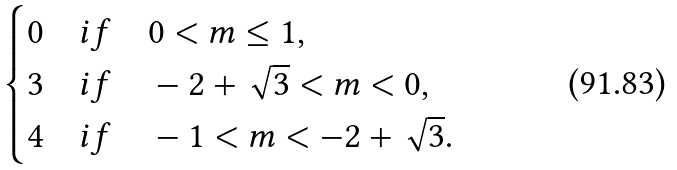<formula> <loc_0><loc_0><loc_500><loc_500>\begin{cases} 0 & i f \quad 0 < m \leq 1 , \\ 3 & i f \quad - 2 + \sqrt { 3 } < m < 0 , \\ 4 & i f \quad - 1 < m < - 2 + \sqrt { 3 } . \end{cases}</formula> 